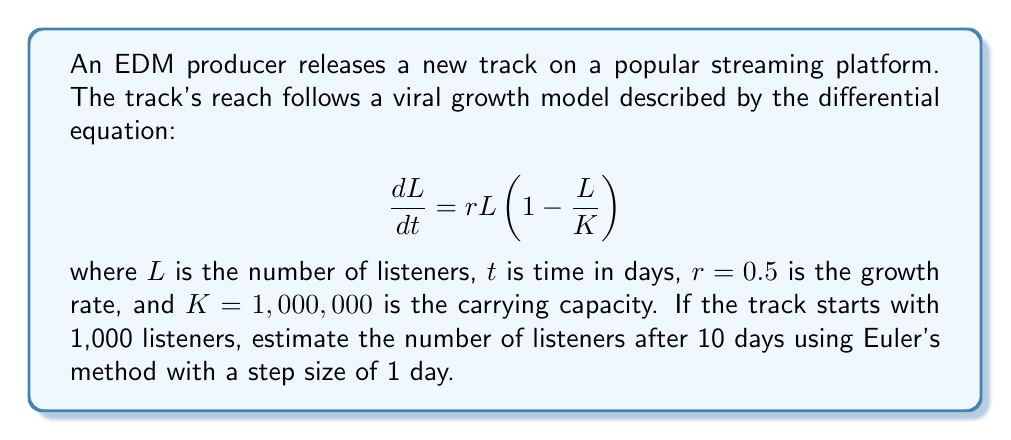Show me your answer to this math problem. To solve this problem, we'll use Euler's method to approximate the solution to the differential equation. Euler's method is given by:

$$L_{n+1} = L_n + h \cdot f(t_n, L_n)$$

where $h$ is the step size, and $f(t, L) = rL(1-\frac{L}{K})$ is the right-hand side of the differential equation.

Given:
- Initial listeners: $L_0 = 1,000$
- Growth rate: $r = 0.5$
- Carrying capacity: $K = 1,000,000$
- Step size: $h = 1$ day
- Number of steps: $n = 10$

Let's calculate the number of listeners for each day:

Day 0: $L_0 = 1,000$

Day 1: $L_1 = L_0 + h \cdot r L_0 (1 - \frac{L_0}{K}) = 1,000 + 1 \cdot 0.5 \cdot 1,000 \cdot (1 - \frac{1,000}{1,000,000}) = 1,499.5$

Day 2: $L_2 = L_1 + h \cdot r L_1 (1 - \frac{L_1}{K}) = 1,499.5 + 1 \cdot 0.5 \cdot 1,499.5 \cdot (1 - \frac{1,499.5}{1,000,000}) = 2,246.3$

Continuing this process for the remaining days:

Day 3: $L_3 = 3,361.6$
Day 4: $L_4 = 5,025.9$
Day 5: $L_5 = 7,501.0$
Day 6: $L_6 = 11,163.0$
Day 7: $L_7 = 16,533.9$
Day 8: $L_8 = 24,340.9$
Day 9: $L_9 = 35,541.7$
Day 10: $L_{10} = 51,365.1$

Therefore, after 10 days, the estimated number of listeners is approximately 51,365.
Answer: 51,365 listeners 